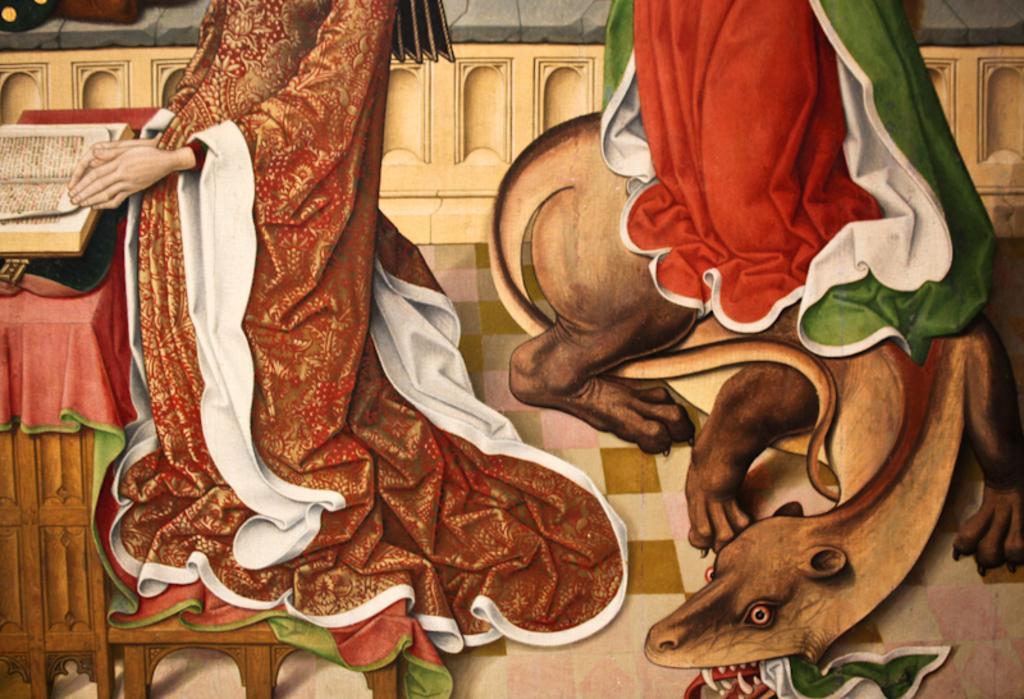How would you summarize this image in a sentence or two? This is a painting in this image there is one person who is standing in front of her there is one table. On the table there is one book and on the right side there is an animal and curtain, in the background there is a wall. At the bottom there is a floor. 